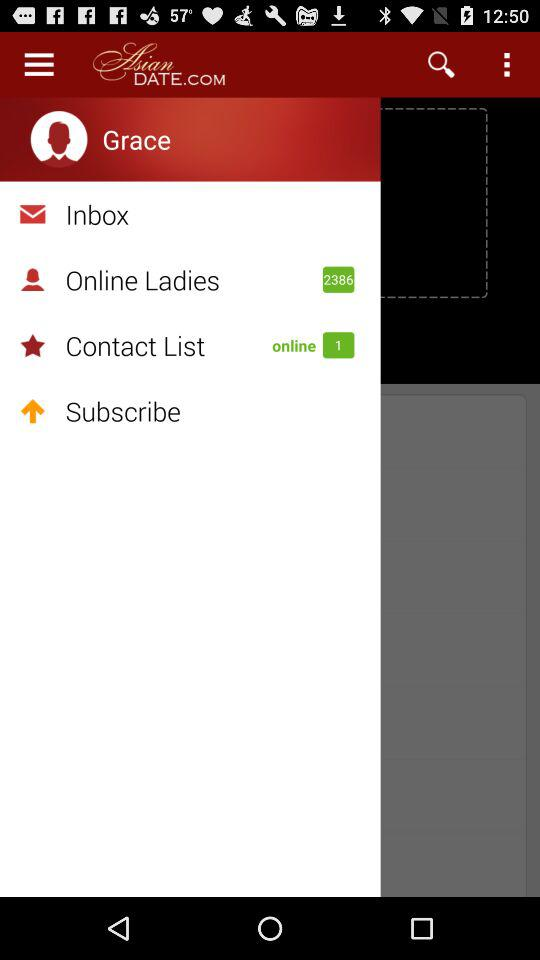How many online contact lists are there? There is only one online contact list. 